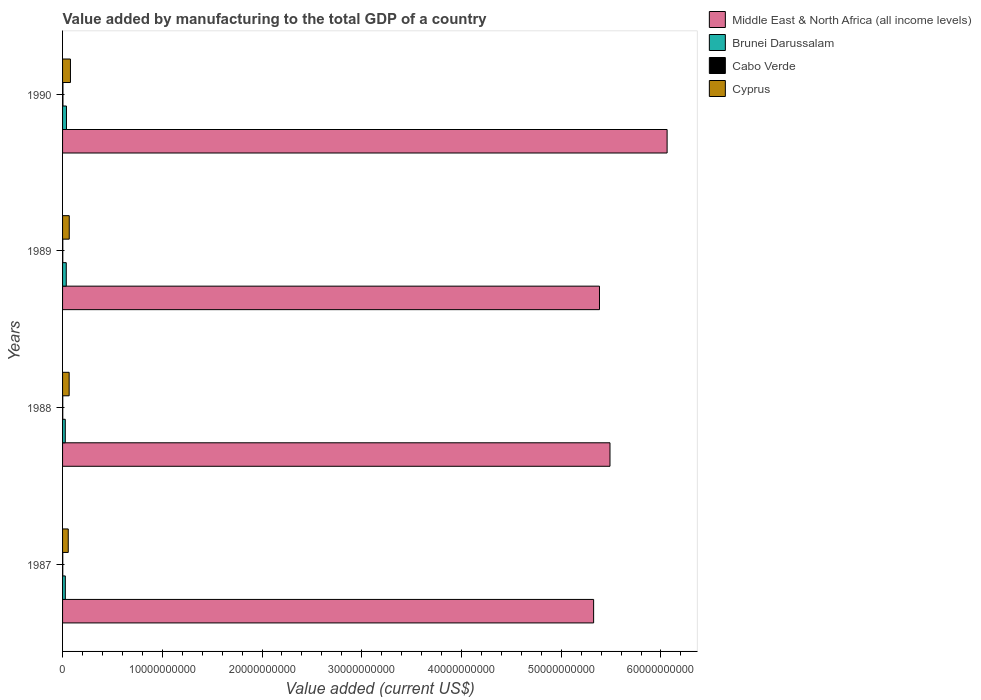Are the number of bars on each tick of the Y-axis equal?
Your response must be concise. Yes. How many bars are there on the 3rd tick from the top?
Provide a short and direct response. 4. In how many cases, is the number of bars for a given year not equal to the number of legend labels?
Keep it short and to the point. 0. What is the value added by manufacturing to the total GDP in Middle East & North Africa (all income levels) in 1987?
Ensure brevity in your answer.  5.32e+1. Across all years, what is the maximum value added by manufacturing to the total GDP in Cyprus?
Provide a succinct answer. 7.92e+08. Across all years, what is the minimum value added by manufacturing to the total GDP in Cyprus?
Offer a terse response. 5.70e+08. In which year was the value added by manufacturing to the total GDP in Cabo Verde minimum?
Give a very brief answer. 1988. What is the total value added by manufacturing to the total GDP in Brunei Darussalam in the graph?
Your response must be concise. 1.31e+09. What is the difference between the value added by manufacturing to the total GDP in Cyprus in 1989 and that in 1990?
Offer a very short reply. -1.21e+08. What is the difference between the value added by manufacturing to the total GDP in Middle East & North Africa (all income levels) in 1990 and the value added by manufacturing to the total GDP in Cabo Verde in 1988?
Give a very brief answer. 6.06e+1. What is the average value added by manufacturing to the total GDP in Cyprus per year?
Provide a short and direct response. 6.73e+08. In the year 1987, what is the difference between the value added by manufacturing to the total GDP in Middle East & North Africa (all income levels) and value added by manufacturing to the total GDP in Brunei Darussalam?
Your answer should be compact. 5.30e+1. What is the ratio of the value added by manufacturing to the total GDP in Brunei Darussalam in 1987 to that in 1988?
Offer a very short reply. 1.02. What is the difference between the highest and the second highest value added by manufacturing to the total GDP in Cabo Verde?
Ensure brevity in your answer.  1.54e+07. What is the difference between the highest and the lowest value added by manufacturing to the total GDP in Cabo Verde?
Your answer should be compact. 1.95e+07. In how many years, is the value added by manufacturing to the total GDP in Brunei Darussalam greater than the average value added by manufacturing to the total GDP in Brunei Darussalam taken over all years?
Give a very brief answer. 2. Is it the case that in every year, the sum of the value added by manufacturing to the total GDP in Middle East & North Africa (all income levels) and value added by manufacturing to the total GDP in Cabo Verde is greater than the sum of value added by manufacturing to the total GDP in Brunei Darussalam and value added by manufacturing to the total GDP in Cyprus?
Your response must be concise. Yes. What does the 2nd bar from the top in 1988 represents?
Keep it short and to the point. Cabo Verde. What does the 3rd bar from the bottom in 1988 represents?
Keep it short and to the point. Cabo Verde. Is it the case that in every year, the sum of the value added by manufacturing to the total GDP in Middle East & North Africa (all income levels) and value added by manufacturing to the total GDP in Cabo Verde is greater than the value added by manufacturing to the total GDP in Brunei Darussalam?
Make the answer very short. Yes. How many bars are there?
Ensure brevity in your answer.  16. What is the difference between two consecutive major ticks on the X-axis?
Keep it short and to the point. 1.00e+1. Are the values on the major ticks of X-axis written in scientific E-notation?
Offer a very short reply. No. Does the graph contain any zero values?
Offer a very short reply. No. Does the graph contain grids?
Your response must be concise. No. Where does the legend appear in the graph?
Your answer should be very brief. Top right. How many legend labels are there?
Give a very brief answer. 4. What is the title of the graph?
Your response must be concise. Value added by manufacturing to the total GDP of a country. Does "Liechtenstein" appear as one of the legend labels in the graph?
Your response must be concise. No. What is the label or title of the X-axis?
Your answer should be compact. Value added (current US$). What is the Value added (current US$) in Middle East & North Africa (all income levels) in 1987?
Your answer should be very brief. 5.32e+1. What is the Value added (current US$) in Brunei Darussalam in 1987?
Provide a short and direct response. 2.77e+08. What is the Value added (current US$) in Cabo Verde in 1987?
Your answer should be compact. 1.99e+07. What is the Value added (current US$) of Cyprus in 1987?
Provide a succinct answer. 5.70e+08. What is the Value added (current US$) in Middle East & North Africa (all income levels) in 1988?
Ensure brevity in your answer.  5.49e+1. What is the Value added (current US$) in Brunei Darussalam in 1988?
Keep it short and to the point. 2.72e+08. What is the Value added (current US$) in Cabo Verde in 1988?
Provide a succinct answer. 1.92e+07. What is the Value added (current US$) of Cyprus in 1988?
Ensure brevity in your answer.  6.62e+08. What is the Value added (current US$) in Middle East & North Africa (all income levels) in 1989?
Keep it short and to the point. 5.38e+1. What is the Value added (current US$) of Brunei Darussalam in 1989?
Provide a succinct answer. 3.71e+08. What is the Value added (current US$) in Cabo Verde in 1989?
Offer a terse response. 2.33e+07. What is the Value added (current US$) in Cyprus in 1989?
Ensure brevity in your answer.  6.71e+08. What is the Value added (current US$) in Middle East & North Africa (all income levels) in 1990?
Your response must be concise. 6.06e+1. What is the Value added (current US$) in Brunei Darussalam in 1990?
Ensure brevity in your answer.  3.92e+08. What is the Value added (current US$) in Cabo Verde in 1990?
Keep it short and to the point. 3.87e+07. What is the Value added (current US$) of Cyprus in 1990?
Provide a succinct answer. 7.92e+08. Across all years, what is the maximum Value added (current US$) in Middle East & North Africa (all income levels)?
Provide a succinct answer. 6.06e+1. Across all years, what is the maximum Value added (current US$) of Brunei Darussalam?
Your answer should be very brief. 3.92e+08. Across all years, what is the maximum Value added (current US$) of Cabo Verde?
Keep it short and to the point. 3.87e+07. Across all years, what is the maximum Value added (current US$) of Cyprus?
Your answer should be very brief. 7.92e+08. Across all years, what is the minimum Value added (current US$) of Middle East & North Africa (all income levels)?
Provide a short and direct response. 5.32e+1. Across all years, what is the minimum Value added (current US$) in Brunei Darussalam?
Your response must be concise. 2.72e+08. Across all years, what is the minimum Value added (current US$) in Cabo Verde?
Your response must be concise. 1.92e+07. Across all years, what is the minimum Value added (current US$) in Cyprus?
Provide a succinct answer. 5.70e+08. What is the total Value added (current US$) in Middle East & North Africa (all income levels) in the graph?
Your answer should be very brief. 2.23e+11. What is the total Value added (current US$) in Brunei Darussalam in the graph?
Make the answer very short. 1.31e+09. What is the total Value added (current US$) in Cabo Verde in the graph?
Your answer should be compact. 1.01e+08. What is the total Value added (current US$) of Cyprus in the graph?
Provide a short and direct response. 2.69e+09. What is the difference between the Value added (current US$) in Middle East & North Africa (all income levels) in 1987 and that in 1988?
Your answer should be very brief. -1.64e+09. What is the difference between the Value added (current US$) in Brunei Darussalam in 1987 and that in 1988?
Provide a succinct answer. 5.01e+06. What is the difference between the Value added (current US$) in Cabo Verde in 1987 and that in 1988?
Offer a very short reply. 6.09e+05. What is the difference between the Value added (current US$) in Cyprus in 1987 and that in 1988?
Ensure brevity in your answer.  -9.20e+07. What is the difference between the Value added (current US$) of Middle East & North Africa (all income levels) in 1987 and that in 1989?
Give a very brief answer. -5.87e+08. What is the difference between the Value added (current US$) in Brunei Darussalam in 1987 and that in 1989?
Give a very brief answer. -9.42e+07. What is the difference between the Value added (current US$) of Cabo Verde in 1987 and that in 1989?
Make the answer very short. -3.42e+06. What is the difference between the Value added (current US$) of Cyprus in 1987 and that in 1989?
Give a very brief answer. -1.01e+08. What is the difference between the Value added (current US$) of Middle East & North Africa (all income levels) in 1987 and that in 1990?
Give a very brief answer. -7.37e+09. What is the difference between the Value added (current US$) in Brunei Darussalam in 1987 and that in 1990?
Give a very brief answer. -1.15e+08. What is the difference between the Value added (current US$) of Cabo Verde in 1987 and that in 1990?
Your answer should be very brief. -1.88e+07. What is the difference between the Value added (current US$) in Cyprus in 1987 and that in 1990?
Make the answer very short. -2.22e+08. What is the difference between the Value added (current US$) in Middle East & North Africa (all income levels) in 1988 and that in 1989?
Make the answer very short. 1.05e+09. What is the difference between the Value added (current US$) in Brunei Darussalam in 1988 and that in 1989?
Ensure brevity in your answer.  -9.92e+07. What is the difference between the Value added (current US$) of Cabo Verde in 1988 and that in 1989?
Your answer should be compact. -4.03e+06. What is the difference between the Value added (current US$) in Cyprus in 1988 and that in 1989?
Keep it short and to the point. -9.13e+06. What is the difference between the Value added (current US$) of Middle East & North Africa (all income levels) in 1988 and that in 1990?
Offer a very short reply. -5.73e+09. What is the difference between the Value added (current US$) in Brunei Darussalam in 1988 and that in 1990?
Ensure brevity in your answer.  -1.20e+08. What is the difference between the Value added (current US$) of Cabo Verde in 1988 and that in 1990?
Keep it short and to the point. -1.95e+07. What is the difference between the Value added (current US$) of Cyprus in 1988 and that in 1990?
Offer a very short reply. -1.30e+08. What is the difference between the Value added (current US$) in Middle East & North Africa (all income levels) in 1989 and that in 1990?
Provide a succinct answer. -6.78e+09. What is the difference between the Value added (current US$) of Brunei Darussalam in 1989 and that in 1990?
Keep it short and to the point. -2.10e+07. What is the difference between the Value added (current US$) of Cabo Verde in 1989 and that in 1990?
Your answer should be very brief. -1.54e+07. What is the difference between the Value added (current US$) of Cyprus in 1989 and that in 1990?
Your answer should be compact. -1.21e+08. What is the difference between the Value added (current US$) in Middle East & North Africa (all income levels) in 1987 and the Value added (current US$) in Brunei Darussalam in 1988?
Ensure brevity in your answer.  5.30e+1. What is the difference between the Value added (current US$) in Middle East & North Africa (all income levels) in 1987 and the Value added (current US$) in Cabo Verde in 1988?
Make the answer very short. 5.32e+1. What is the difference between the Value added (current US$) in Middle East & North Africa (all income levels) in 1987 and the Value added (current US$) in Cyprus in 1988?
Keep it short and to the point. 5.26e+1. What is the difference between the Value added (current US$) of Brunei Darussalam in 1987 and the Value added (current US$) of Cabo Verde in 1988?
Make the answer very short. 2.58e+08. What is the difference between the Value added (current US$) in Brunei Darussalam in 1987 and the Value added (current US$) in Cyprus in 1988?
Ensure brevity in your answer.  -3.85e+08. What is the difference between the Value added (current US$) in Cabo Verde in 1987 and the Value added (current US$) in Cyprus in 1988?
Provide a short and direct response. -6.42e+08. What is the difference between the Value added (current US$) of Middle East & North Africa (all income levels) in 1987 and the Value added (current US$) of Brunei Darussalam in 1989?
Provide a short and direct response. 5.29e+1. What is the difference between the Value added (current US$) of Middle East & North Africa (all income levels) in 1987 and the Value added (current US$) of Cabo Verde in 1989?
Keep it short and to the point. 5.32e+1. What is the difference between the Value added (current US$) of Middle East & North Africa (all income levels) in 1987 and the Value added (current US$) of Cyprus in 1989?
Your answer should be very brief. 5.26e+1. What is the difference between the Value added (current US$) of Brunei Darussalam in 1987 and the Value added (current US$) of Cabo Verde in 1989?
Your response must be concise. 2.54e+08. What is the difference between the Value added (current US$) of Brunei Darussalam in 1987 and the Value added (current US$) of Cyprus in 1989?
Your answer should be compact. -3.94e+08. What is the difference between the Value added (current US$) in Cabo Verde in 1987 and the Value added (current US$) in Cyprus in 1989?
Ensure brevity in your answer.  -6.51e+08. What is the difference between the Value added (current US$) of Middle East & North Africa (all income levels) in 1987 and the Value added (current US$) of Brunei Darussalam in 1990?
Your answer should be compact. 5.29e+1. What is the difference between the Value added (current US$) in Middle East & North Africa (all income levels) in 1987 and the Value added (current US$) in Cabo Verde in 1990?
Your answer should be compact. 5.32e+1. What is the difference between the Value added (current US$) of Middle East & North Africa (all income levels) in 1987 and the Value added (current US$) of Cyprus in 1990?
Provide a succinct answer. 5.25e+1. What is the difference between the Value added (current US$) of Brunei Darussalam in 1987 and the Value added (current US$) of Cabo Verde in 1990?
Your answer should be very brief. 2.38e+08. What is the difference between the Value added (current US$) in Brunei Darussalam in 1987 and the Value added (current US$) in Cyprus in 1990?
Provide a short and direct response. -5.15e+08. What is the difference between the Value added (current US$) of Cabo Verde in 1987 and the Value added (current US$) of Cyprus in 1990?
Your answer should be very brief. -7.72e+08. What is the difference between the Value added (current US$) in Middle East & North Africa (all income levels) in 1988 and the Value added (current US$) in Brunei Darussalam in 1989?
Provide a short and direct response. 5.45e+1. What is the difference between the Value added (current US$) in Middle East & North Africa (all income levels) in 1988 and the Value added (current US$) in Cabo Verde in 1989?
Your response must be concise. 5.49e+1. What is the difference between the Value added (current US$) of Middle East & North Africa (all income levels) in 1988 and the Value added (current US$) of Cyprus in 1989?
Ensure brevity in your answer.  5.42e+1. What is the difference between the Value added (current US$) in Brunei Darussalam in 1988 and the Value added (current US$) in Cabo Verde in 1989?
Offer a terse response. 2.49e+08. What is the difference between the Value added (current US$) of Brunei Darussalam in 1988 and the Value added (current US$) of Cyprus in 1989?
Provide a succinct answer. -3.99e+08. What is the difference between the Value added (current US$) of Cabo Verde in 1988 and the Value added (current US$) of Cyprus in 1989?
Offer a very short reply. -6.51e+08. What is the difference between the Value added (current US$) of Middle East & North Africa (all income levels) in 1988 and the Value added (current US$) of Brunei Darussalam in 1990?
Your answer should be very brief. 5.45e+1. What is the difference between the Value added (current US$) in Middle East & North Africa (all income levels) in 1988 and the Value added (current US$) in Cabo Verde in 1990?
Your answer should be compact. 5.49e+1. What is the difference between the Value added (current US$) of Middle East & North Africa (all income levels) in 1988 and the Value added (current US$) of Cyprus in 1990?
Give a very brief answer. 5.41e+1. What is the difference between the Value added (current US$) of Brunei Darussalam in 1988 and the Value added (current US$) of Cabo Verde in 1990?
Make the answer very short. 2.33e+08. What is the difference between the Value added (current US$) of Brunei Darussalam in 1988 and the Value added (current US$) of Cyprus in 1990?
Keep it short and to the point. -5.20e+08. What is the difference between the Value added (current US$) in Cabo Verde in 1988 and the Value added (current US$) in Cyprus in 1990?
Offer a very short reply. -7.72e+08. What is the difference between the Value added (current US$) of Middle East & North Africa (all income levels) in 1989 and the Value added (current US$) of Brunei Darussalam in 1990?
Give a very brief answer. 5.34e+1. What is the difference between the Value added (current US$) of Middle East & North Africa (all income levels) in 1989 and the Value added (current US$) of Cabo Verde in 1990?
Ensure brevity in your answer.  5.38e+1. What is the difference between the Value added (current US$) in Middle East & North Africa (all income levels) in 1989 and the Value added (current US$) in Cyprus in 1990?
Your answer should be compact. 5.30e+1. What is the difference between the Value added (current US$) in Brunei Darussalam in 1989 and the Value added (current US$) in Cabo Verde in 1990?
Make the answer very short. 3.32e+08. What is the difference between the Value added (current US$) of Brunei Darussalam in 1989 and the Value added (current US$) of Cyprus in 1990?
Your answer should be very brief. -4.21e+08. What is the difference between the Value added (current US$) of Cabo Verde in 1989 and the Value added (current US$) of Cyprus in 1990?
Ensure brevity in your answer.  -7.68e+08. What is the average Value added (current US$) of Middle East & North Africa (all income levels) per year?
Ensure brevity in your answer.  5.56e+1. What is the average Value added (current US$) of Brunei Darussalam per year?
Your answer should be compact. 3.28e+08. What is the average Value added (current US$) of Cabo Verde per year?
Offer a very short reply. 2.53e+07. What is the average Value added (current US$) of Cyprus per year?
Offer a very short reply. 6.73e+08. In the year 1987, what is the difference between the Value added (current US$) in Middle East & North Africa (all income levels) and Value added (current US$) in Brunei Darussalam?
Keep it short and to the point. 5.30e+1. In the year 1987, what is the difference between the Value added (current US$) of Middle East & North Africa (all income levels) and Value added (current US$) of Cabo Verde?
Offer a terse response. 5.32e+1. In the year 1987, what is the difference between the Value added (current US$) of Middle East & North Africa (all income levels) and Value added (current US$) of Cyprus?
Your answer should be compact. 5.27e+1. In the year 1987, what is the difference between the Value added (current US$) in Brunei Darussalam and Value added (current US$) in Cabo Verde?
Offer a very short reply. 2.57e+08. In the year 1987, what is the difference between the Value added (current US$) in Brunei Darussalam and Value added (current US$) in Cyprus?
Ensure brevity in your answer.  -2.93e+08. In the year 1987, what is the difference between the Value added (current US$) of Cabo Verde and Value added (current US$) of Cyprus?
Ensure brevity in your answer.  -5.50e+08. In the year 1988, what is the difference between the Value added (current US$) in Middle East & North Africa (all income levels) and Value added (current US$) in Brunei Darussalam?
Give a very brief answer. 5.46e+1. In the year 1988, what is the difference between the Value added (current US$) of Middle East & North Africa (all income levels) and Value added (current US$) of Cabo Verde?
Keep it short and to the point. 5.49e+1. In the year 1988, what is the difference between the Value added (current US$) in Middle East & North Africa (all income levels) and Value added (current US$) in Cyprus?
Keep it short and to the point. 5.42e+1. In the year 1988, what is the difference between the Value added (current US$) in Brunei Darussalam and Value added (current US$) in Cabo Verde?
Offer a very short reply. 2.53e+08. In the year 1988, what is the difference between the Value added (current US$) in Brunei Darussalam and Value added (current US$) in Cyprus?
Keep it short and to the point. -3.90e+08. In the year 1988, what is the difference between the Value added (current US$) of Cabo Verde and Value added (current US$) of Cyprus?
Make the answer very short. -6.42e+08. In the year 1989, what is the difference between the Value added (current US$) of Middle East & North Africa (all income levels) and Value added (current US$) of Brunei Darussalam?
Offer a very short reply. 5.35e+1. In the year 1989, what is the difference between the Value added (current US$) of Middle East & North Africa (all income levels) and Value added (current US$) of Cabo Verde?
Give a very brief answer. 5.38e+1. In the year 1989, what is the difference between the Value added (current US$) of Middle East & North Africa (all income levels) and Value added (current US$) of Cyprus?
Ensure brevity in your answer.  5.32e+1. In the year 1989, what is the difference between the Value added (current US$) of Brunei Darussalam and Value added (current US$) of Cabo Verde?
Make the answer very short. 3.48e+08. In the year 1989, what is the difference between the Value added (current US$) of Brunei Darussalam and Value added (current US$) of Cyprus?
Make the answer very short. -3.00e+08. In the year 1989, what is the difference between the Value added (current US$) of Cabo Verde and Value added (current US$) of Cyprus?
Ensure brevity in your answer.  -6.47e+08. In the year 1990, what is the difference between the Value added (current US$) of Middle East & North Africa (all income levels) and Value added (current US$) of Brunei Darussalam?
Offer a terse response. 6.02e+1. In the year 1990, what is the difference between the Value added (current US$) of Middle East & North Africa (all income levels) and Value added (current US$) of Cabo Verde?
Offer a very short reply. 6.06e+1. In the year 1990, what is the difference between the Value added (current US$) in Middle East & North Africa (all income levels) and Value added (current US$) in Cyprus?
Provide a short and direct response. 5.98e+1. In the year 1990, what is the difference between the Value added (current US$) of Brunei Darussalam and Value added (current US$) of Cabo Verde?
Your answer should be compact. 3.53e+08. In the year 1990, what is the difference between the Value added (current US$) in Brunei Darussalam and Value added (current US$) in Cyprus?
Offer a very short reply. -3.99e+08. In the year 1990, what is the difference between the Value added (current US$) of Cabo Verde and Value added (current US$) of Cyprus?
Offer a very short reply. -7.53e+08. What is the ratio of the Value added (current US$) of Middle East & North Africa (all income levels) in 1987 to that in 1988?
Offer a very short reply. 0.97. What is the ratio of the Value added (current US$) in Brunei Darussalam in 1987 to that in 1988?
Give a very brief answer. 1.02. What is the ratio of the Value added (current US$) of Cabo Verde in 1987 to that in 1988?
Offer a very short reply. 1.03. What is the ratio of the Value added (current US$) of Cyprus in 1987 to that in 1988?
Give a very brief answer. 0.86. What is the ratio of the Value added (current US$) of Brunei Darussalam in 1987 to that in 1989?
Your answer should be compact. 0.75. What is the ratio of the Value added (current US$) of Cabo Verde in 1987 to that in 1989?
Offer a very short reply. 0.85. What is the ratio of the Value added (current US$) in Cyprus in 1987 to that in 1989?
Offer a terse response. 0.85. What is the ratio of the Value added (current US$) in Middle East & North Africa (all income levels) in 1987 to that in 1990?
Provide a succinct answer. 0.88. What is the ratio of the Value added (current US$) in Brunei Darussalam in 1987 to that in 1990?
Your response must be concise. 0.71. What is the ratio of the Value added (current US$) of Cabo Verde in 1987 to that in 1990?
Offer a terse response. 0.51. What is the ratio of the Value added (current US$) of Cyprus in 1987 to that in 1990?
Ensure brevity in your answer.  0.72. What is the ratio of the Value added (current US$) in Middle East & North Africa (all income levels) in 1988 to that in 1989?
Offer a terse response. 1.02. What is the ratio of the Value added (current US$) of Brunei Darussalam in 1988 to that in 1989?
Your answer should be very brief. 0.73. What is the ratio of the Value added (current US$) in Cabo Verde in 1988 to that in 1989?
Your response must be concise. 0.83. What is the ratio of the Value added (current US$) of Cyprus in 1988 to that in 1989?
Make the answer very short. 0.99. What is the ratio of the Value added (current US$) in Middle East & North Africa (all income levels) in 1988 to that in 1990?
Give a very brief answer. 0.91. What is the ratio of the Value added (current US$) of Brunei Darussalam in 1988 to that in 1990?
Your answer should be very brief. 0.69. What is the ratio of the Value added (current US$) of Cabo Verde in 1988 to that in 1990?
Ensure brevity in your answer.  0.5. What is the ratio of the Value added (current US$) in Cyprus in 1988 to that in 1990?
Give a very brief answer. 0.84. What is the ratio of the Value added (current US$) in Middle East & North Africa (all income levels) in 1989 to that in 1990?
Keep it short and to the point. 0.89. What is the ratio of the Value added (current US$) of Brunei Darussalam in 1989 to that in 1990?
Offer a terse response. 0.95. What is the ratio of the Value added (current US$) in Cabo Verde in 1989 to that in 1990?
Offer a terse response. 0.6. What is the ratio of the Value added (current US$) of Cyprus in 1989 to that in 1990?
Give a very brief answer. 0.85. What is the difference between the highest and the second highest Value added (current US$) in Middle East & North Africa (all income levels)?
Give a very brief answer. 5.73e+09. What is the difference between the highest and the second highest Value added (current US$) of Brunei Darussalam?
Your response must be concise. 2.10e+07. What is the difference between the highest and the second highest Value added (current US$) of Cabo Verde?
Ensure brevity in your answer.  1.54e+07. What is the difference between the highest and the second highest Value added (current US$) in Cyprus?
Your response must be concise. 1.21e+08. What is the difference between the highest and the lowest Value added (current US$) of Middle East & North Africa (all income levels)?
Give a very brief answer. 7.37e+09. What is the difference between the highest and the lowest Value added (current US$) of Brunei Darussalam?
Ensure brevity in your answer.  1.20e+08. What is the difference between the highest and the lowest Value added (current US$) of Cabo Verde?
Give a very brief answer. 1.95e+07. What is the difference between the highest and the lowest Value added (current US$) of Cyprus?
Give a very brief answer. 2.22e+08. 